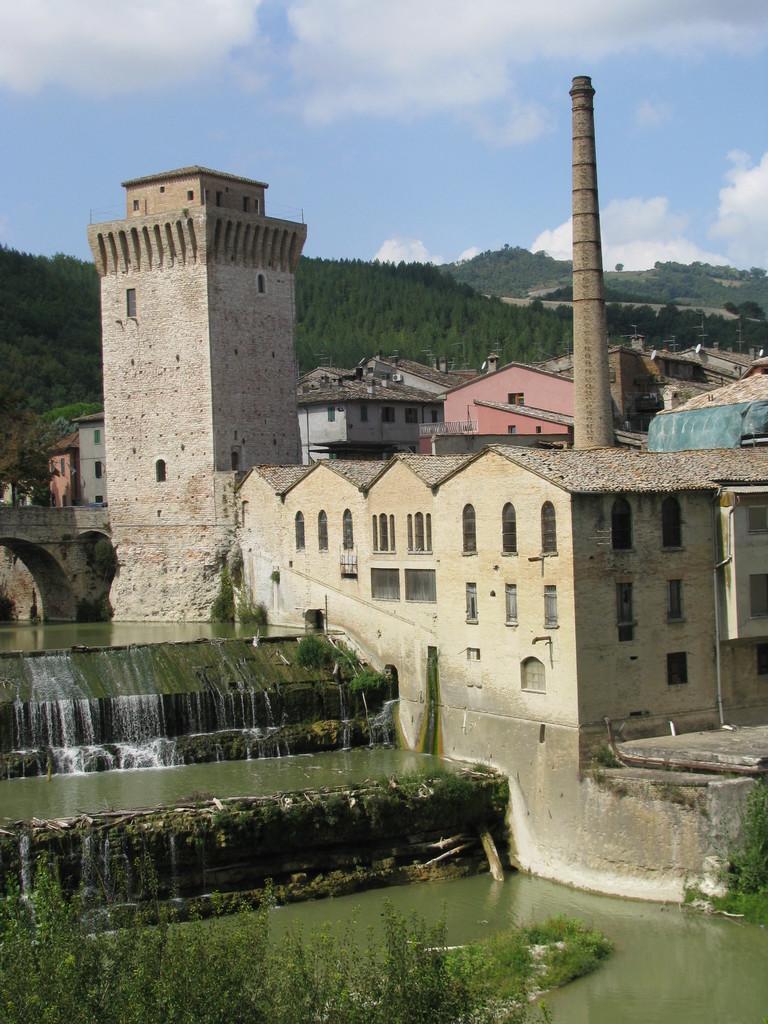How would you summarize this image in a sentence or two? In this image we can see the water, trees, stone houses, bridge, hills with trees and the cloudy sky in the background. 